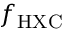Convert formula to latex. <formula><loc_0><loc_0><loc_500><loc_500>f _ { H X C }</formula> 